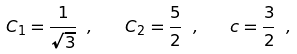Convert formula to latex. <formula><loc_0><loc_0><loc_500><loc_500>C _ { 1 } = \frac { 1 } { \sqrt { 3 } } \ , \quad C _ { 2 } = \frac { 5 } { 2 } \ , \quad c = \frac { 3 } { 2 } \ ,</formula> 